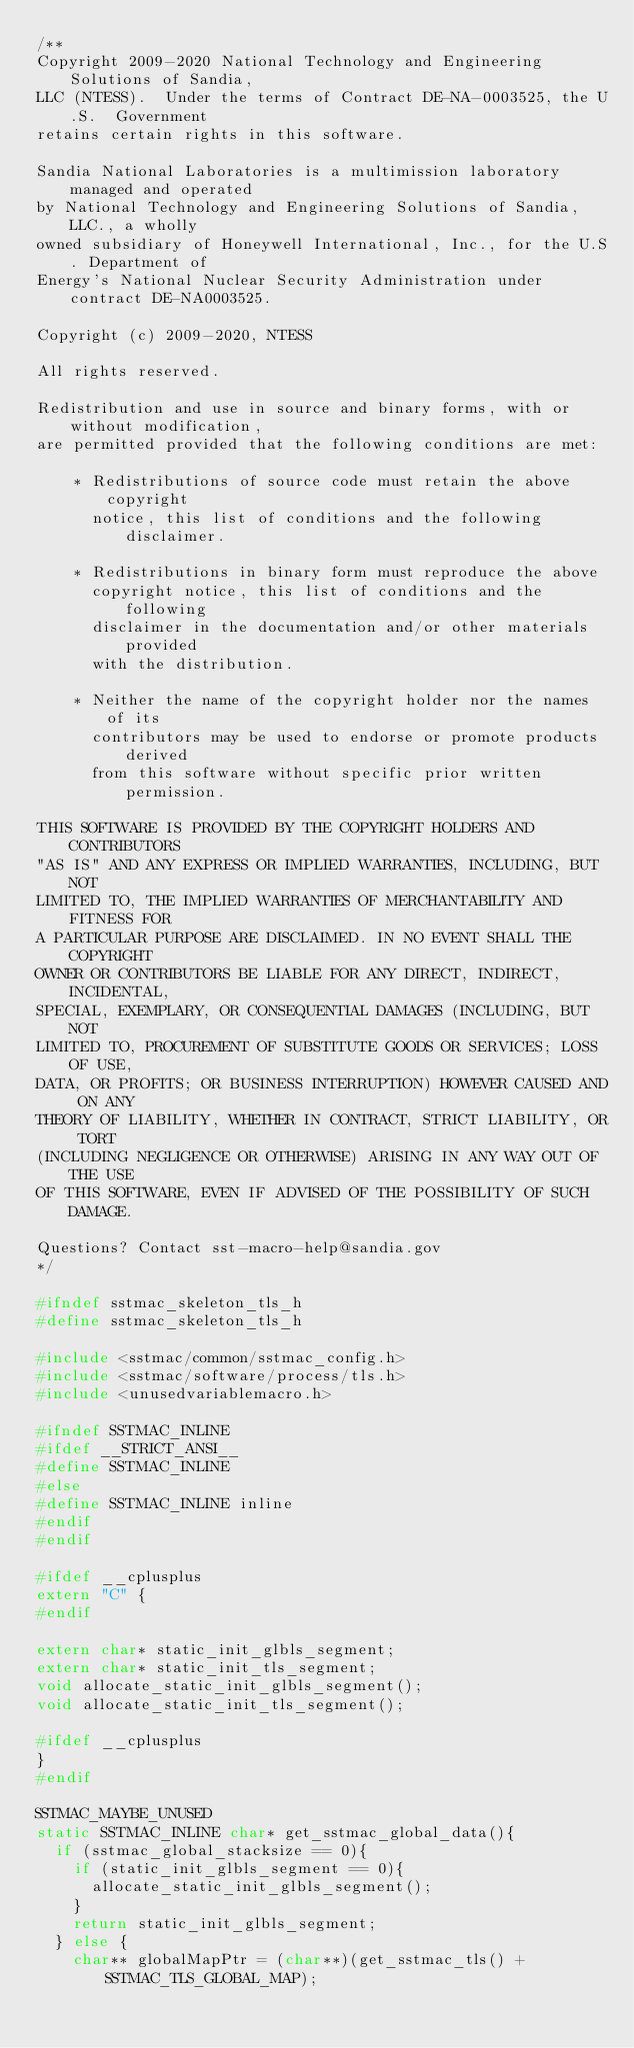Convert code to text. <code><loc_0><loc_0><loc_500><loc_500><_C_>/**
Copyright 2009-2020 National Technology and Engineering Solutions of Sandia, 
LLC (NTESS).  Under the terms of Contract DE-NA-0003525, the U.S.  Government 
retains certain rights in this software.

Sandia National Laboratories is a multimission laboratory managed and operated
by National Technology and Engineering Solutions of Sandia, LLC., a wholly 
owned subsidiary of Honeywell International, Inc., for the U.S. Department of 
Energy's National Nuclear Security Administration under contract DE-NA0003525.

Copyright (c) 2009-2020, NTESS

All rights reserved.

Redistribution and use in source and binary forms, with or without modification, 
are permitted provided that the following conditions are met:

    * Redistributions of source code must retain the above copyright
      notice, this list of conditions and the following disclaimer.

    * Redistributions in binary form must reproduce the above
      copyright notice, this list of conditions and the following
      disclaimer in the documentation and/or other materials provided
      with the distribution.

    * Neither the name of the copyright holder nor the names of its
      contributors may be used to endorse or promote products derived
      from this software without specific prior written permission.

THIS SOFTWARE IS PROVIDED BY THE COPYRIGHT HOLDERS AND CONTRIBUTORS
"AS IS" AND ANY EXPRESS OR IMPLIED WARRANTIES, INCLUDING, BUT NOT
LIMITED TO, THE IMPLIED WARRANTIES OF MERCHANTABILITY AND FITNESS FOR
A PARTICULAR PURPOSE ARE DISCLAIMED. IN NO EVENT SHALL THE COPYRIGHT
OWNER OR CONTRIBUTORS BE LIABLE FOR ANY DIRECT, INDIRECT, INCIDENTAL,
SPECIAL, EXEMPLARY, OR CONSEQUENTIAL DAMAGES (INCLUDING, BUT NOT
LIMITED TO, PROCUREMENT OF SUBSTITUTE GOODS OR SERVICES; LOSS OF USE,
DATA, OR PROFITS; OR BUSINESS INTERRUPTION) HOWEVER CAUSED AND ON ANY
THEORY OF LIABILITY, WHETHER IN CONTRACT, STRICT LIABILITY, OR TORT
(INCLUDING NEGLIGENCE OR OTHERWISE) ARISING IN ANY WAY OUT OF THE USE
OF THIS SOFTWARE, EVEN IF ADVISED OF THE POSSIBILITY OF SUCH DAMAGE.

Questions? Contact sst-macro-help@sandia.gov
*/

#ifndef sstmac_skeleton_tls_h
#define sstmac_skeleton_tls_h

#include <sstmac/common/sstmac_config.h>
#include <sstmac/software/process/tls.h>
#include <unusedvariablemacro.h>

#ifndef SSTMAC_INLINE
#ifdef __STRICT_ANSI__
#define SSTMAC_INLINE
#else
#define SSTMAC_INLINE inline
#endif
#endif

#ifdef __cplusplus
extern "C" {
#endif

extern char* static_init_glbls_segment;
extern char* static_init_tls_segment;
void allocate_static_init_glbls_segment();
void allocate_static_init_tls_segment();

#ifdef __cplusplus
}
#endif

SSTMAC_MAYBE_UNUSED
static SSTMAC_INLINE char* get_sstmac_global_data(){
  if (sstmac_global_stacksize == 0){
    if (static_init_glbls_segment == 0){
      allocate_static_init_glbls_segment();
    }
    return static_init_glbls_segment;
  } else {
    char** globalMapPtr = (char**)(get_sstmac_tls() + SSTMAC_TLS_GLOBAL_MAP);</code> 